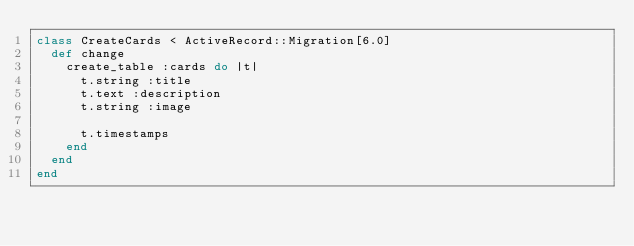<code> <loc_0><loc_0><loc_500><loc_500><_Ruby_>class CreateCards < ActiveRecord::Migration[6.0]
  def change
    create_table :cards do |t|
      t.string :title
      t.text :description
      t.string :image

      t.timestamps
    end
  end
end
</code> 